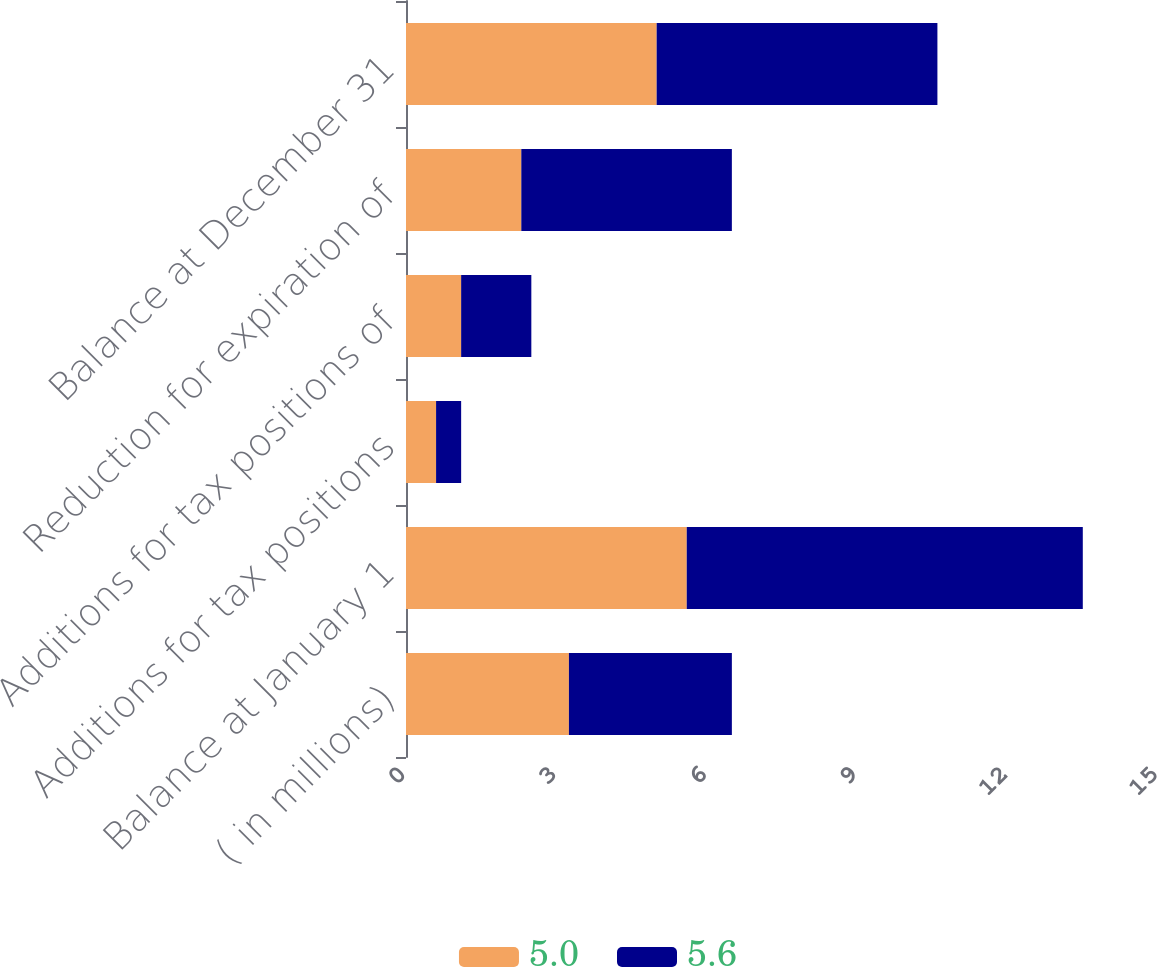Convert chart to OTSL. <chart><loc_0><loc_0><loc_500><loc_500><stacked_bar_chart><ecel><fcel>( in millions)<fcel>Balance at January 1<fcel>Additions for tax positions<fcel>Additions for tax positions of<fcel>Reduction for expiration of<fcel>Balance at December 31<nl><fcel>5<fcel>3.25<fcel>5.6<fcel>0.6<fcel>1.1<fcel>2.3<fcel>5<nl><fcel>5.6<fcel>3.25<fcel>7.9<fcel>0.5<fcel>1.4<fcel>4.2<fcel>5.6<nl></chart> 